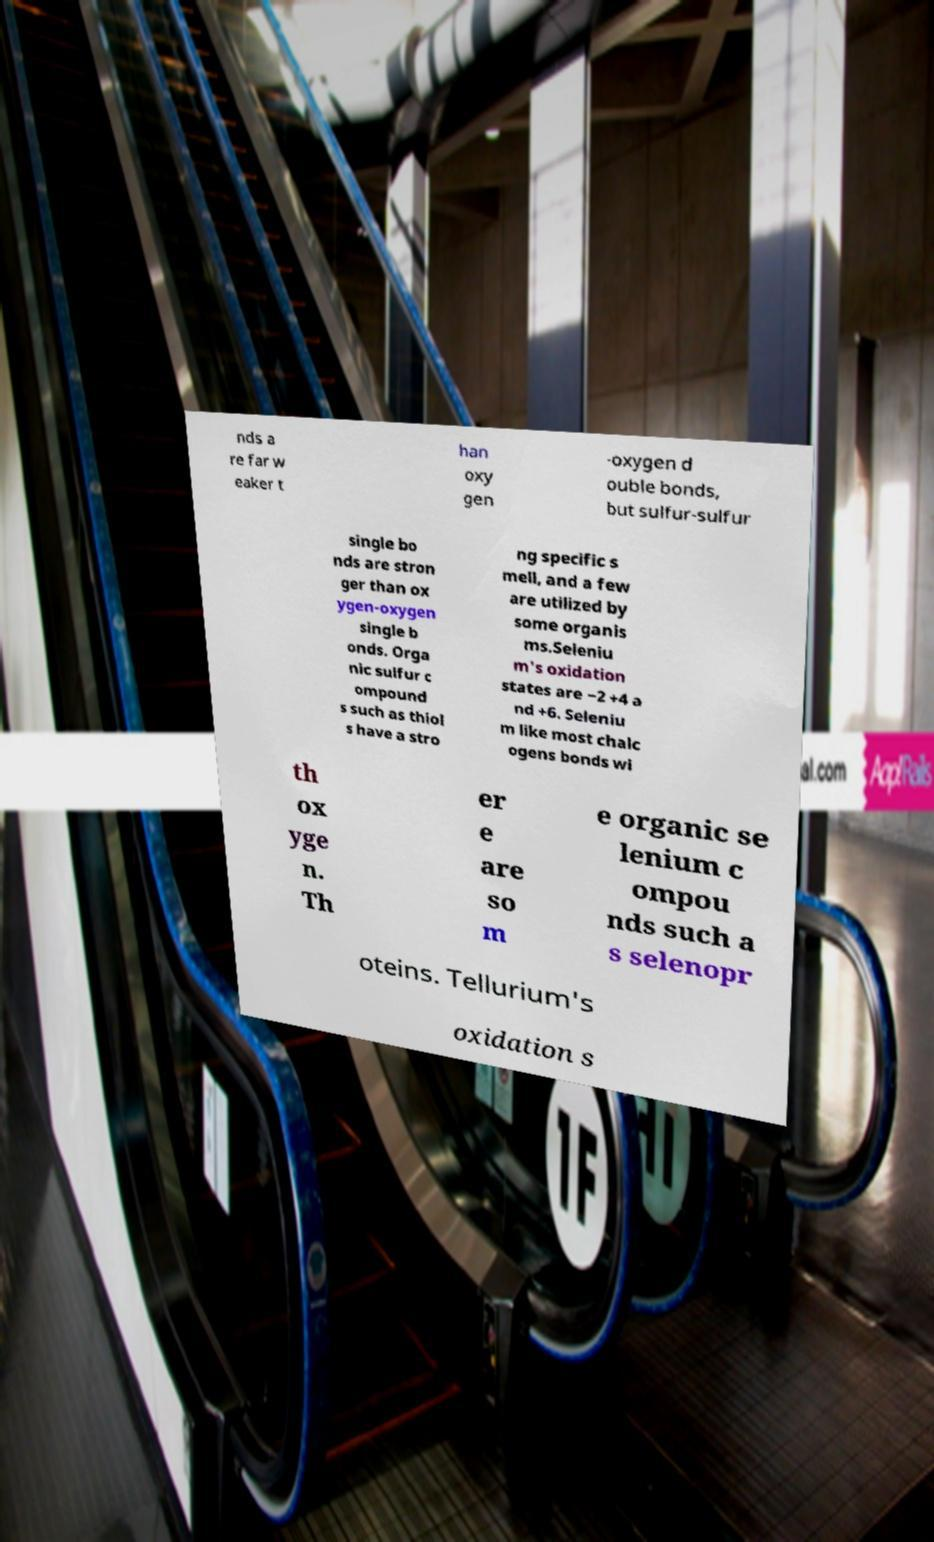Please identify and transcribe the text found in this image. nds a re far w eaker t han oxy gen -oxygen d ouble bonds, but sulfur-sulfur single bo nds are stron ger than ox ygen-oxygen single b onds. Orga nic sulfur c ompound s such as thiol s have a stro ng specific s mell, and a few are utilized by some organis ms.Seleniu m's oxidation states are −2 +4 a nd +6. Seleniu m like most chalc ogens bonds wi th ox yge n. Th er e are so m e organic se lenium c ompou nds such a s selenopr oteins. Tellurium's oxidation s 